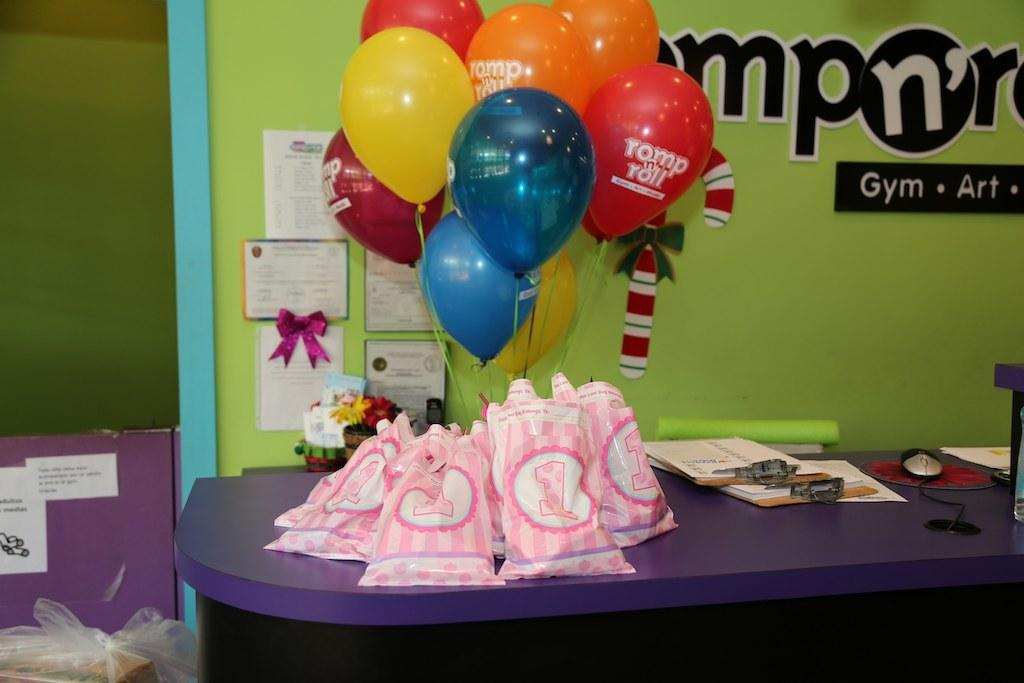What objects are on the table in the image? There are covers, papers, a mouse, cables, and balloons on the table in the image. What can be seen in the background of the image? There are posters and a banner in the background. What might the mouse be used for on the table? The mouse is likely used for controlling a computer or device, as it is a common input device. How many balloons are visible on the table? There are balloons on the table, but the exact number is not specified in the facts. How does the mouse attack the papers on the table? There is no indication in the image that the mouse is attacking the papers or engaging in any aggressive behavior. 